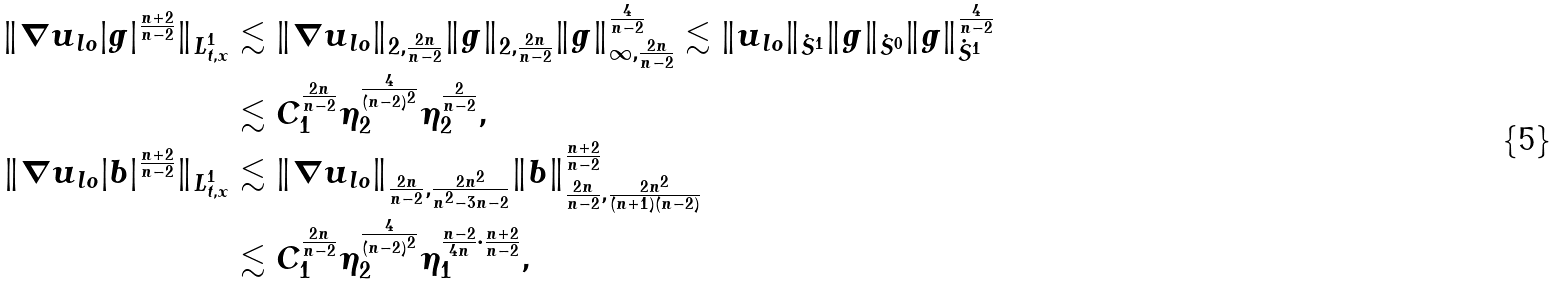<formula> <loc_0><loc_0><loc_500><loc_500>\| \nabla u _ { l o } | g | ^ { \frac { n + 2 } { n - 2 } } \| _ { L _ { t , x } ^ { 1 } } & \lesssim \| \nabla u _ { l o } \| _ { 2 , \frac { 2 n } { n - 2 } } \| g \| _ { 2 , \frac { 2 n } { n - 2 } } \| g \| _ { \infty , \frac { 2 n } { n - 2 } } ^ { \frac { 4 } { n - 2 } } \lesssim \| u _ { l o } \| _ { \dot { S } ^ { 1 } } \| g \| _ { \dot { S } ^ { 0 } } \| g \| _ { \dot { S } ^ { 1 } } ^ { \frac { 4 } { n - 2 } } \\ & \lesssim C _ { 1 } ^ { \frac { 2 n } { n - 2 } } \eta _ { 2 } ^ { \frac { 4 } { ( n - 2 ) ^ { 2 } } } \eta _ { 2 } ^ { \frac { 2 } { n - 2 } } , \\ \| \nabla u _ { l o } | b | ^ { \frac { n + 2 } { n - 2 } } \| _ { L _ { t , x } ^ { 1 } } & \lesssim \| \nabla u _ { l o } \| _ { \frac { 2 n } { n - 2 } , \frac { 2 n ^ { 2 } } { n ^ { 2 } - 3 n - 2 } } \| b \| ^ { \frac { n + 2 } { n - 2 } } _ { \frac { 2 n } { n - 2 } , \frac { 2 n ^ { 2 } } { ( n + 1 ) ( n - 2 ) } } \\ & \lesssim C _ { 1 } ^ { \frac { 2 n } { n - 2 } } \eta _ { 2 } ^ { \frac { 4 } { ( n - 2 ) ^ { 2 } } } \eta _ { 1 } ^ { \frac { n - 2 } { 4 n } \cdot \frac { n + 2 } { n - 2 } } ,</formula> 